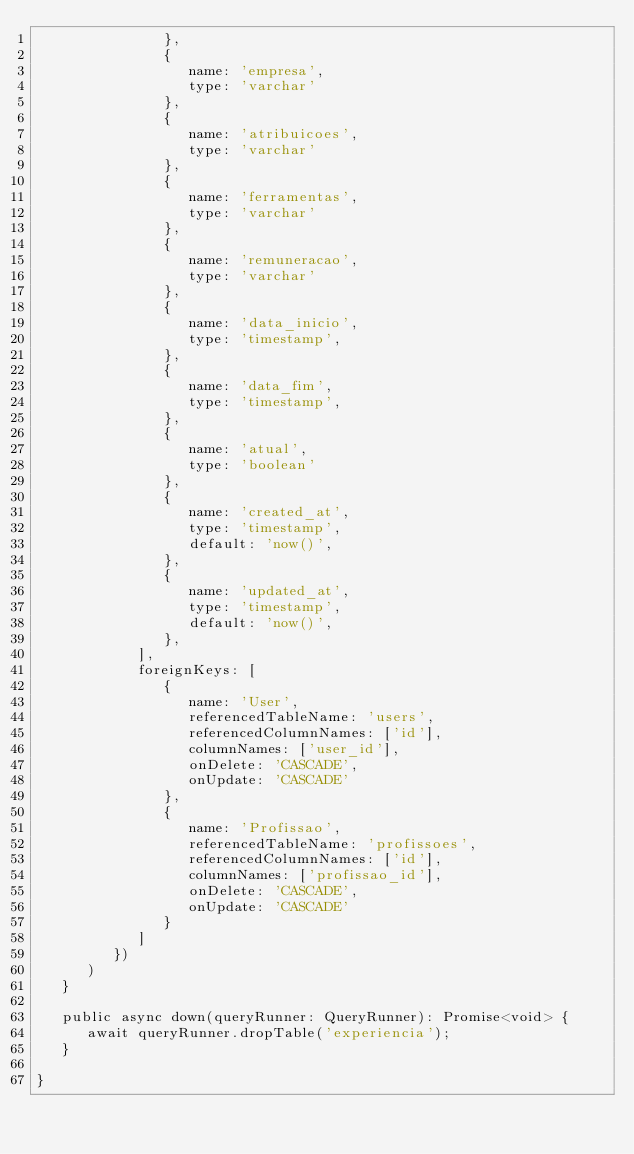Convert code to text. <code><loc_0><loc_0><loc_500><loc_500><_TypeScript_>               },
               {
                  name: 'empresa',
                  type: 'varchar'
               },
               {
                  name: 'atribuicoes',
                  type: 'varchar'
               },
               {
                  name: 'ferramentas',
                  type: 'varchar'
               },
               {
                  name: 'remuneracao',
                  type: 'varchar'
               },
               {
                  name: 'data_inicio',
                  type: 'timestamp',
               },
               {
                  name: 'data_fim',
                  type: 'timestamp',
               },
               {
                  name: 'atual',
                  type: 'boolean'
               },
               {
                  name: 'created_at',
                  type: 'timestamp',
                  default: 'now()',
               },
               {
                  name: 'updated_at',
                  type: 'timestamp',
                  default: 'now()',
               },
            ],
            foreignKeys: [
               {
                  name: 'User',
                  referencedTableName: 'users',
                  referencedColumnNames: ['id'],
                  columnNames: ['user_id'],
                  onDelete: 'CASCADE',
                  onUpdate: 'CASCADE'
               },
               {
                  name: 'Profissao',
                  referencedTableName: 'profissoes',
                  referencedColumnNames: ['id'],
                  columnNames: ['profissao_id'],
                  onDelete: 'CASCADE',
                  onUpdate: 'CASCADE'
               }
            ]
         })
      )
   }

   public async down(queryRunner: QueryRunner): Promise<void> {
      await queryRunner.dropTable('experiencia');
   }

}
</code> 